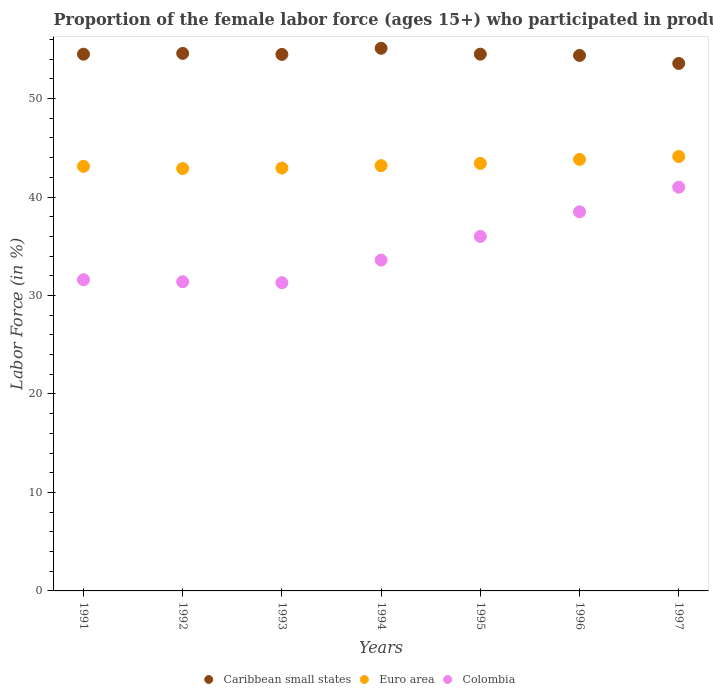How many different coloured dotlines are there?
Your response must be concise. 3. Is the number of dotlines equal to the number of legend labels?
Provide a succinct answer. Yes. What is the proportion of the female labor force who participated in production in Caribbean small states in 1995?
Your response must be concise. 54.51. Across all years, what is the maximum proportion of the female labor force who participated in production in Colombia?
Your response must be concise. 41. Across all years, what is the minimum proportion of the female labor force who participated in production in Colombia?
Keep it short and to the point. 31.3. In which year was the proportion of the female labor force who participated in production in Caribbean small states maximum?
Your response must be concise. 1994. What is the total proportion of the female labor force who participated in production in Colombia in the graph?
Ensure brevity in your answer.  243.4. What is the difference between the proportion of the female labor force who participated in production in Caribbean small states in 1993 and that in 1996?
Keep it short and to the point. 0.11. What is the difference between the proportion of the female labor force who participated in production in Caribbean small states in 1993 and the proportion of the female labor force who participated in production in Euro area in 1997?
Provide a succinct answer. 10.37. What is the average proportion of the female labor force who participated in production in Colombia per year?
Offer a terse response. 34.77. In the year 1994, what is the difference between the proportion of the female labor force who participated in production in Caribbean small states and proportion of the female labor force who participated in production in Colombia?
Your response must be concise. 21.51. In how many years, is the proportion of the female labor force who participated in production in Caribbean small states greater than 26 %?
Ensure brevity in your answer.  7. What is the ratio of the proportion of the female labor force who participated in production in Euro area in 1991 to that in 1995?
Provide a succinct answer. 0.99. Is the difference between the proportion of the female labor force who participated in production in Caribbean small states in 1993 and 1995 greater than the difference between the proportion of the female labor force who participated in production in Colombia in 1993 and 1995?
Keep it short and to the point. Yes. What is the difference between the highest and the second highest proportion of the female labor force who participated in production in Euro area?
Provide a succinct answer. 0.29. What is the difference between the highest and the lowest proportion of the female labor force who participated in production in Euro area?
Keep it short and to the point. 1.22. Is the sum of the proportion of the female labor force who participated in production in Colombia in 1994 and 1996 greater than the maximum proportion of the female labor force who participated in production in Caribbean small states across all years?
Keep it short and to the point. Yes. Is it the case that in every year, the sum of the proportion of the female labor force who participated in production in Colombia and proportion of the female labor force who participated in production in Euro area  is greater than the proportion of the female labor force who participated in production in Caribbean small states?
Make the answer very short. Yes. Does the proportion of the female labor force who participated in production in Colombia monotonically increase over the years?
Ensure brevity in your answer.  No. How many years are there in the graph?
Make the answer very short. 7. Does the graph contain grids?
Your answer should be compact. No. Where does the legend appear in the graph?
Provide a short and direct response. Bottom center. What is the title of the graph?
Your answer should be compact. Proportion of the female labor force (ages 15+) who participated in production. What is the label or title of the Y-axis?
Give a very brief answer. Labor Force (in %). What is the Labor Force (in %) of Caribbean small states in 1991?
Make the answer very short. 54.51. What is the Labor Force (in %) of Euro area in 1991?
Keep it short and to the point. 43.12. What is the Labor Force (in %) in Colombia in 1991?
Provide a succinct answer. 31.6. What is the Labor Force (in %) of Caribbean small states in 1992?
Offer a very short reply. 54.59. What is the Labor Force (in %) in Euro area in 1992?
Ensure brevity in your answer.  42.89. What is the Labor Force (in %) in Colombia in 1992?
Your answer should be compact. 31.4. What is the Labor Force (in %) in Caribbean small states in 1993?
Your response must be concise. 54.49. What is the Labor Force (in %) of Euro area in 1993?
Your answer should be compact. 42.95. What is the Labor Force (in %) of Colombia in 1993?
Ensure brevity in your answer.  31.3. What is the Labor Force (in %) in Caribbean small states in 1994?
Your answer should be very brief. 55.11. What is the Labor Force (in %) in Euro area in 1994?
Offer a terse response. 43.19. What is the Labor Force (in %) of Colombia in 1994?
Keep it short and to the point. 33.6. What is the Labor Force (in %) in Caribbean small states in 1995?
Offer a very short reply. 54.51. What is the Labor Force (in %) of Euro area in 1995?
Keep it short and to the point. 43.42. What is the Labor Force (in %) of Colombia in 1995?
Make the answer very short. 36. What is the Labor Force (in %) of Caribbean small states in 1996?
Provide a succinct answer. 54.38. What is the Labor Force (in %) in Euro area in 1996?
Make the answer very short. 43.82. What is the Labor Force (in %) of Colombia in 1996?
Give a very brief answer. 38.5. What is the Labor Force (in %) in Caribbean small states in 1997?
Provide a succinct answer. 53.57. What is the Labor Force (in %) of Euro area in 1997?
Provide a succinct answer. 44.11. What is the Labor Force (in %) in Colombia in 1997?
Keep it short and to the point. 41. Across all years, what is the maximum Labor Force (in %) of Caribbean small states?
Your response must be concise. 55.11. Across all years, what is the maximum Labor Force (in %) in Euro area?
Your answer should be very brief. 44.11. Across all years, what is the minimum Labor Force (in %) of Caribbean small states?
Make the answer very short. 53.57. Across all years, what is the minimum Labor Force (in %) in Euro area?
Your answer should be very brief. 42.89. Across all years, what is the minimum Labor Force (in %) of Colombia?
Keep it short and to the point. 31.3. What is the total Labor Force (in %) in Caribbean small states in the graph?
Keep it short and to the point. 381.14. What is the total Labor Force (in %) in Euro area in the graph?
Make the answer very short. 303.5. What is the total Labor Force (in %) in Colombia in the graph?
Your answer should be compact. 243.4. What is the difference between the Labor Force (in %) of Caribbean small states in 1991 and that in 1992?
Provide a short and direct response. -0.08. What is the difference between the Labor Force (in %) of Euro area in 1991 and that in 1992?
Make the answer very short. 0.22. What is the difference between the Labor Force (in %) of Colombia in 1991 and that in 1992?
Your answer should be very brief. 0.2. What is the difference between the Labor Force (in %) of Caribbean small states in 1991 and that in 1993?
Offer a terse response. 0.02. What is the difference between the Labor Force (in %) in Euro area in 1991 and that in 1993?
Ensure brevity in your answer.  0.17. What is the difference between the Labor Force (in %) of Caribbean small states in 1991 and that in 1994?
Offer a very short reply. -0.6. What is the difference between the Labor Force (in %) of Euro area in 1991 and that in 1994?
Keep it short and to the point. -0.07. What is the difference between the Labor Force (in %) in Colombia in 1991 and that in 1994?
Your answer should be very brief. -2. What is the difference between the Labor Force (in %) in Caribbean small states in 1991 and that in 1995?
Offer a terse response. -0. What is the difference between the Labor Force (in %) of Euro area in 1991 and that in 1995?
Your response must be concise. -0.3. What is the difference between the Labor Force (in %) in Colombia in 1991 and that in 1995?
Give a very brief answer. -4.4. What is the difference between the Labor Force (in %) of Caribbean small states in 1991 and that in 1996?
Make the answer very short. 0.13. What is the difference between the Labor Force (in %) of Euro area in 1991 and that in 1996?
Make the answer very short. -0.7. What is the difference between the Labor Force (in %) in Colombia in 1991 and that in 1996?
Keep it short and to the point. -6.9. What is the difference between the Labor Force (in %) in Caribbean small states in 1991 and that in 1997?
Offer a terse response. 0.94. What is the difference between the Labor Force (in %) of Euro area in 1991 and that in 1997?
Offer a very short reply. -0.99. What is the difference between the Labor Force (in %) in Caribbean small states in 1992 and that in 1993?
Provide a succinct answer. 0.1. What is the difference between the Labor Force (in %) in Euro area in 1992 and that in 1993?
Keep it short and to the point. -0.05. What is the difference between the Labor Force (in %) of Colombia in 1992 and that in 1993?
Your answer should be compact. 0.1. What is the difference between the Labor Force (in %) in Caribbean small states in 1992 and that in 1994?
Offer a terse response. -0.52. What is the difference between the Labor Force (in %) of Euro area in 1992 and that in 1994?
Ensure brevity in your answer.  -0.29. What is the difference between the Labor Force (in %) of Caribbean small states in 1992 and that in 1995?
Provide a short and direct response. 0.08. What is the difference between the Labor Force (in %) of Euro area in 1992 and that in 1995?
Provide a succinct answer. -0.52. What is the difference between the Labor Force (in %) of Colombia in 1992 and that in 1995?
Keep it short and to the point. -4.6. What is the difference between the Labor Force (in %) of Caribbean small states in 1992 and that in 1996?
Your answer should be compact. 0.21. What is the difference between the Labor Force (in %) of Euro area in 1992 and that in 1996?
Give a very brief answer. -0.93. What is the difference between the Labor Force (in %) of Caribbean small states in 1992 and that in 1997?
Your response must be concise. 1.02. What is the difference between the Labor Force (in %) of Euro area in 1992 and that in 1997?
Keep it short and to the point. -1.22. What is the difference between the Labor Force (in %) in Caribbean small states in 1993 and that in 1994?
Provide a succinct answer. -0.62. What is the difference between the Labor Force (in %) in Euro area in 1993 and that in 1994?
Offer a terse response. -0.24. What is the difference between the Labor Force (in %) in Colombia in 1993 and that in 1994?
Your answer should be compact. -2.3. What is the difference between the Labor Force (in %) of Caribbean small states in 1993 and that in 1995?
Ensure brevity in your answer.  -0.02. What is the difference between the Labor Force (in %) of Euro area in 1993 and that in 1995?
Offer a very short reply. -0.47. What is the difference between the Labor Force (in %) of Caribbean small states in 1993 and that in 1996?
Your answer should be compact. 0.11. What is the difference between the Labor Force (in %) of Euro area in 1993 and that in 1996?
Keep it short and to the point. -0.87. What is the difference between the Labor Force (in %) of Caribbean small states in 1993 and that in 1997?
Your answer should be compact. 0.92. What is the difference between the Labor Force (in %) of Euro area in 1993 and that in 1997?
Your response must be concise. -1.17. What is the difference between the Labor Force (in %) of Caribbean small states in 1994 and that in 1995?
Ensure brevity in your answer.  0.6. What is the difference between the Labor Force (in %) in Euro area in 1994 and that in 1995?
Give a very brief answer. -0.23. What is the difference between the Labor Force (in %) in Colombia in 1994 and that in 1995?
Your answer should be very brief. -2.4. What is the difference between the Labor Force (in %) in Caribbean small states in 1994 and that in 1996?
Offer a terse response. 0.73. What is the difference between the Labor Force (in %) in Euro area in 1994 and that in 1996?
Your answer should be compact. -0.63. What is the difference between the Labor Force (in %) in Colombia in 1994 and that in 1996?
Provide a succinct answer. -4.9. What is the difference between the Labor Force (in %) in Caribbean small states in 1994 and that in 1997?
Your response must be concise. 1.54. What is the difference between the Labor Force (in %) of Euro area in 1994 and that in 1997?
Give a very brief answer. -0.92. What is the difference between the Labor Force (in %) of Colombia in 1994 and that in 1997?
Offer a terse response. -7.4. What is the difference between the Labor Force (in %) of Caribbean small states in 1995 and that in 1996?
Ensure brevity in your answer.  0.13. What is the difference between the Labor Force (in %) in Euro area in 1995 and that in 1996?
Keep it short and to the point. -0.4. What is the difference between the Labor Force (in %) in Colombia in 1995 and that in 1996?
Offer a terse response. -2.5. What is the difference between the Labor Force (in %) in Caribbean small states in 1995 and that in 1997?
Provide a short and direct response. 0.94. What is the difference between the Labor Force (in %) in Euro area in 1995 and that in 1997?
Your answer should be very brief. -0.69. What is the difference between the Labor Force (in %) in Colombia in 1995 and that in 1997?
Your answer should be very brief. -5. What is the difference between the Labor Force (in %) in Caribbean small states in 1996 and that in 1997?
Your response must be concise. 0.81. What is the difference between the Labor Force (in %) of Euro area in 1996 and that in 1997?
Provide a succinct answer. -0.29. What is the difference between the Labor Force (in %) in Colombia in 1996 and that in 1997?
Offer a terse response. -2.5. What is the difference between the Labor Force (in %) of Caribbean small states in 1991 and the Labor Force (in %) of Euro area in 1992?
Your response must be concise. 11.61. What is the difference between the Labor Force (in %) in Caribbean small states in 1991 and the Labor Force (in %) in Colombia in 1992?
Make the answer very short. 23.11. What is the difference between the Labor Force (in %) in Euro area in 1991 and the Labor Force (in %) in Colombia in 1992?
Ensure brevity in your answer.  11.72. What is the difference between the Labor Force (in %) of Caribbean small states in 1991 and the Labor Force (in %) of Euro area in 1993?
Provide a succinct answer. 11.56. What is the difference between the Labor Force (in %) in Caribbean small states in 1991 and the Labor Force (in %) in Colombia in 1993?
Keep it short and to the point. 23.21. What is the difference between the Labor Force (in %) in Euro area in 1991 and the Labor Force (in %) in Colombia in 1993?
Provide a succinct answer. 11.82. What is the difference between the Labor Force (in %) in Caribbean small states in 1991 and the Labor Force (in %) in Euro area in 1994?
Give a very brief answer. 11.32. What is the difference between the Labor Force (in %) of Caribbean small states in 1991 and the Labor Force (in %) of Colombia in 1994?
Your answer should be very brief. 20.91. What is the difference between the Labor Force (in %) in Euro area in 1991 and the Labor Force (in %) in Colombia in 1994?
Offer a terse response. 9.52. What is the difference between the Labor Force (in %) of Caribbean small states in 1991 and the Labor Force (in %) of Euro area in 1995?
Provide a succinct answer. 11.09. What is the difference between the Labor Force (in %) in Caribbean small states in 1991 and the Labor Force (in %) in Colombia in 1995?
Keep it short and to the point. 18.51. What is the difference between the Labor Force (in %) in Euro area in 1991 and the Labor Force (in %) in Colombia in 1995?
Make the answer very short. 7.12. What is the difference between the Labor Force (in %) of Caribbean small states in 1991 and the Labor Force (in %) of Euro area in 1996?
Give a very brief answer. 10.69. What is the difference between the Labor Force (in %) in Caribbean small states in 1991 and the Labor Force (in %) in Colombia in 1996?
Offer a terse response. 16.01. What is the difference between the Labor Force (in %) in Euro area in 1991 and the Labor Force (in %) in Colombia in 1996?
Your answer should be compact. 4.62. What is the difference between the Labor Force (in %) in Caribbean small states in 1991 and the Labor Force (in %) in Euro area in 1997?
Make the answer very short. 10.39. What is the difference between the Labor Force (in %) in Caribbean small states in 1991 and the Labor Force (in %) in Colombia in 1997?
Keep it short and to the point. 13.51. What is the difference between the Labor Force (in %) of Euro area in 1991 and the Labor Force (in %) of Colombia in 1997?
Your answer should be very brief. 2.12. What is the difference between the Labor Force (in %) of Caribbean small states in 1992 and the Labor Force (in %) of Euro area in 1993?
Keep it short and to the point. 11.64. What is the difference between the Labor Force (in %) in Caribbean small states in 1992 and the Labor Force (in %) in Colombia in 1993?
Provide a short and direct response. 23.29. What is the difference between the Labor Force (in %) in Euro area in 1992 and the Labor Force (in %) in Colombia in 1993?
Your answer should be compact. 11.59. What is the difference between the Labor Force (in %) of Caribbean small states in 1992 and the Labor Force (in %) of Euro area in 1994?
Your response must be concise. 11.4. What is the difference between the Labor Force (in %) of Caribbean small states in 1992 and the Labor Force (in %) of Colombia in 1994?
Your answer should be very brief. 20.99. What is the difference between the Labor Force (in %) of Euro area in 1992 and the Labor Force (in %) of Colombia in 1994?
Provide a short and direct response. 9.29. What is the difference between the Labor Force (in %) in Caribbean small states in 1992 and the Labor Force (in %) in Euro area in 1995?
Offer a very short reply. 11.17. What is the difference between the Labor Force (in %) of Caribbean small states in 1992 and the Labor Force (in %) of Colombia in 1995?
Ensure brevity in your answer.  18.59. What is the difference between the Labor Force (in %) of Euro area in 1992 and the Labor Force (in %) of Colombia in 1995?
Offer a very short reply. 6.89. What is the difference between the Labor Force (in %) of Caribbean small states in 1992 and the Labor Force (in %) of Euro area in 1996?
Your answer should be very brief. 10.77. What is the difference between the Labor Force (in %) in Caribbean small states in 1992 and the Labor Force (in %) in Colombia in 1996?
Give a very brief answer. 16.09. What is the difference between the Labor Force (in %) of Euro area in 1992 and the Labor Force (in %) of Colombia in 1996?
Ensure brevity in your answer.  4.39. What is the difference between the Labor Force (in %) of Caribbean small states in 1992 and the Labor Force (in %) of Euro area in 1997?
Provide a short and direct response. 10.47. What is the difference between the Labor Force (in %) in Caribbean small states in 1992 and the Labor Force (in %) in Colombia in 1997?
Provide a short and direct response. 13.59. What is the difference between the Labor Force (in %) of Euro area in 1992 and the Labor Force (in %) of Colombia in 1997?
Give a very brief answer. 1.89. What is the difference between the Labor Force (in %) in Caribbean small states in 1993 and the Labor Force (in %) in Euro area in 1994?
Offer a very short reply. 11.3. What is the difference between the Labor Force (in %) in Caribbean small states in 1993 and the Labor Force (in %) in Colombia in 1994?
Your response must be concise. 20.89. What is the difference between the Labor Force (in %) of Euro area in 1993 and the Labor Force (in %) of Colombia in 1994?
Provide a succinct answer. 9.35. What is the difference between the Labor Force (in %) of Caribbean small states in 1993 and the Labor Force (in %) of Euro area in 1995?
Keep it short and to the point. 11.07. What is the difference between the Labor Force (in %) of Caribbean small states in 1993 and the Labor Force (in %) of Colombia in 1995?
Your answer should be very brief. 18.49. What is the difference between the Labor Force (in %) in Euro area in 1993 and the Labor Force (in %) in Colombia in 1995?
Your response must be concise. 6.95. What is the difference between the Labor Force (in %) in Caribbean small states in 1993 and the Labor Force (in %) in Euro area in 1996?
Provide a succinct answer. 10.66. What is the difference between the Labor Force (in %) in Caribbean small states in 1993 and the Labor Force (in %) in Colombia in 1996?
Your response must be concise. 15.99. What is the difference between the Labor Force (in %) of Euro area in 1993 and the Labor Force (in %) of Colombia in 1996?
Your answer should be very brief. 4.45. What is the difference between the Labor Force (in %) of Caribbean small states in 1993 and the Labor Force (in %) of Euro area in 1997?
Offer a very short reply. 10.37. What is the difference between the Labor Force (in %) of Caribbean small states in 1993 and the Labor Force (in %) of Colombia in 1997?
Provide a succinct answer. 13.49. What is the difference between the Labor Force (in %) of Euro area in 1993 and the Labor Force (in %) of Colombia in 1997?
Your response must be concise. 1.95. What is the difference between the Labor Force (in %) in Caribbean small states in 1994 and the Labor Force (in %) in Euro area in 1995?
Offer a terse response. 11.69. What is the difference between the Labor Force (in %) of Caribbean small states in 1994 and the Labor Force (in %) of Colombia in 1995?
Provide a succinct answer. 19.11. What is the difference between the Labor Force (in %) of Euro area in 1994 and the Labor Force (in %) of Colombia in 1995?
Your answer should be compact. 7.19. What is the difference between the Labor Force (in %) of Caribbean small states in 1994 and the Labor Force (in %) of Euro area in 1996?
Provide a short and direct response. 11.28. What is the difference between the Labor Force (in %) in Caribbean small states in 1994 and the Labor Force (in %) in Colombia in 1996?
Offer a terse response. 16.61. What is the difference between the Labor Force (in %) in Euro area in 1994 and the Labor Force (in %) in Colombia in 1996?
Make the answer very short. 4.69. What is the difference between the Labor Force (in %) of Caribbean small states in 1994 and the Labor Force (in %) of Euro area in 1997?
Offer a terse response. 10.99. What is the difference between the Labor Force (in %) in Caribbean small states in 1994 and the Labor Force (in %) in Colombia in 1997?
Offer a terse response. 14.11. What is the difference between the Labor Force (in %) in Euro area in 1994 and the Labor Force (in %) in Colombia in 1997?
Your answer should be very brief. 2.19. What is the difference between the Labor Force (in %) of Caribbean small states in 1995 and the Labor Force (in %) of Euro area in 1996?
Your response must be concise. 10.69. What is the difference between the Labor Force (in %) of Caribbean small states in 1995 and the Labor Force (in %) of Colombia in 1996?
Keep it short and to the point. 16.01. What is the difference between the Labor Force (in %) of Euro area in 1995 and the Labor Force (in %) of Colombia in 1996?
Offer a very short reply. 4.92. What is the difference between the Labor Force (in %) of Caribbean small states in 1995 and the Labor Force (in %) of Euro area in 1997?
Offer a terse response. 10.4. What is the difference between the Labor Force (in %) of Caribbean small states in 1995 and the Labor Force (in %) of Colombia in 1997?
Your answer should be compact. 13.51. What is the difference between the Labor Force (in %) of Euro area in 1995 and the Labor Force (in %) of Colombia in 1997?
Ensure brevity in your answer.  2.42. What is the difference between the Labor Force (in %) in Caribbean small states in 1996 and the Labor Force (in %) in Euro area in 1997?
Your answer should be very brief. 10.27. What is the difference between the Labor Force (in %) of Caribbean small states in 1996 and the Labor Force (in %) of Colombia in 1997?
Ensure brevity in your answer.  13.38. What is the difference between the Labor Force (in %) of Euro area in 1996 and the Labor Force (in %) of Colombia in 1997?
Provide a succinct answer. 2.82. What is the average Labor Force (in %) of Caribbean small states per year?
Make the answer very short. 54.45. What is the average Labor Force (in %) in Euro area per year?
Give a very brief answer. 43.36. What is the average Labor Force (in %) in Colombia per year?
Provide a short and direct response. 34.77. In the year 1991, what is the difference between the Labor Force (in %) in Caribbean small states and Labor Force (in %) in Euro area?
Provide a short and direct response. 11.39. In the year 1991, what is the difference between the Labor Force (in %) in Caribbean small states and Labor Force (in %) in Colombia?
Give a very brief answer. 22.91. In the year 1991, what is the difference between the Labor Force (in %) of Euro area and Labor Force (in %) of Colombia?
Offer a terse response. 11.52. In the year 1992, what is the difference between the Labor Force (in %) in Caribbean small states and Labor Force (in %) in Euro area?
Offer a very short reply. 11.69. In the year 1992, what is the difference between the Labor Force (in %) in Caribbean small states and Labor Force (in %) in Colombia?
Give a very brief answer. 23.19. In the year 1992, what is the difference between the Labor Force (in %) in Euro area and Labor Force (in %) in Colombia?
Your answer should be very brief. 11.49. In the year 1993, what is the difference between the Labor Force (in %) of Caribbean small states and Labor Force (in %) of Euro area?
Give a very brief answer. 11.54. In the year 1993, what is the difference between the Labor Force (in %) in Caribbean small states and Labor Force (in %) in Colombia?
Your response must be concise. 23.19. In the year 1993, what is the difference between the Labor Force (in %) in Euro area and Labor Force (in %) in Colombia?
Give a very brief answer. 11.65. In the year 1994, what is the difference between the Labor Force (in %) of Caribbean small states and Labor Force (in %) of Euro area?
Your response must be concise. 11.92. In the year 1994, what is the difference between the Labor Force (in %) in Caribbean small states and Labor Force (in %) in Colombia?
Your answer should be very brief. 21.51. In the year 1994, what is the difference between the Labor Force (in %) in Euro area and Labor Force (in %) in Colombia?
Your response must be concise. 9.59. In the year 1995, what is the difference between the Labor Force (in %) in Caribbean small states and Labor Force (in %) in Euro area?
Offer a terse response. 11.09. In the year 1995, what is the difference between the Labor Force (in %) in Caribbean small states and Labor Force (in %) in Colombia?
Give a very brief answer. 18.51. In the year 1995, what is the difference between the Labor Force (in %) of Euro area and Labor Force (in %) of Colombia?
Provide a short and direct response. 7.42. In the year 1996, what is the difference between the Labor Force (in %) in Caribbean small states and Labor Force (in %) in Euro area?
Make the answer very short. 10.56. In the year 1996, what is the difference between the Labor Force (in %) of Caribbean small states and Labor Force (in %) of Colombia?
Keep it short and to the point. 15.88. In the year 1996, what is the difference between the Labor Force (in %) in Euro area and Labor Force (in %) in Colombia?
Offer a terse response. 5.32. In the year 1997, what is the difference between the Labor Force (in %) in Caribbean small states and Labor Force (in %) in Euro area?
Offer a terse response. 9.45. In the year 1997, what is the difference between the Labor Force (in %) in Caribbean small states and Labor Force (in %) in Colombia?
Ensure brevity in your answer.  12.57. In the year 1997, what is the difference between the Labor Force (in %) of Euro area and Labor Force (in %) of Colombia?
Ensure brevity in your answer.  3.11. What is the ratio of the Labor Force (in %) of Euro area in 1991 to that in 1992?
Provide a short and direct response. 1.01. What is the ratio of the Labor Force (in %) in Colombia in 1991 to that in 1992?
Keep it short and to the point. 1.01. What is the ratio of the Labor Force (in %) of Colombia in 1991 to that in 1993?
Give a very brief answer. 1.01. What is the ratio of the Labor Force (in %) in Euro area in 1991 to that in 1994?
Offer a terse response. 1. What is the ratio of the Labor Force (in %) of Colombia in 1991 to that in 1994?
Provide a short and direct response. 0.94. What is the ratio of the Labor Force (in %) of Euro area in 1991 to that in 1995?
Offer a terse response. 0.99. What is the ratio of the Labor Force (in %) of Colombia in 1991 to that in 1995?
Ensure brevity in your answer.  0.88. What is the ratio of the Labor Force (in %) of Caribbean small states in 1991 to that in 1996?
Your answer should be compact. 1. What is the ratio of the Labor Force (in %) in Euro area in 1991 to that in 1996?
Your answer should be very brief. 0.98. What is the ratio of the Labor Force (in %) of Colombia in 1991 to that in 1996?
Offer a terse response. 0.82. What is the ratio of the Labor Force (in %) in Caribbean small states in 1991 to that in 1997?
Your answer should be compact. 1.02. What is the ratio of the Labor Force (in %) of Euro area in 1991 to that in 1997?
Your response must be concise. 0.98. What is the ratio of the Labor Force (in %) of Colombia in 1991 to that in 1997?
Keep it short and to the point. 0.77. What is the ratio of the Labor Force (in %) in Colombia in 1992 to that in 1993?
Your answer should be very brief. 1. What is the ratio of the Labor Force (in %) in Caribbean small states in 1992 to that in 1994?
Offer a very short reply. 0.99. What is the ratio of the Labor Force (in %) of Euro area in 1992 to that in 1994?
Offer a very short reply. 0.99. What is the ratio of the Labor Force (in %) of Colombia in 1992 to that in 1994?
Give a very brief answer. 0.93. What is the ratio of the Labor Force (in %) of Euro area in 1992 to that in 1995?
Ensure brevity in your answer.  0.99. What is the ratio of the Labor Force (in %) of Colombia in 1992 to that in 1995?
Your answer should be compact. 0.87. What is the ratio of the Labor Force (in %) of Caribbean small states in 1992 to that in 1996?
Keep it short and to the point. 1. What is the ratio of the Labor Force (in %) in Euro area in 1992 to that in 1996?
Give a very brief answer. 0.98. What is the ratio of the Labor Force (in %) in Colombia in 1992 to that in 1996?
Provide a succinct answer. 0.82. What is the ratio of the Labor Force (in %) in Caribbean small states in 1992 to that in 1997?
Give a very brief answer. 1.02. What is the ratio of the Labor Force (in %) of Euro area in 1992 to that in 1997?
Give a very brief answer. 0.97. What is the ratio of the Labor Force (in %) of Colombia in 1992 to that in 1997?
Give a very brief answer. 0.77. What is the ratio of the Labor Force (in %) in Caribbean small states in 1993 to that in 1994?
Give a very brief answer. 0.99. What is the ratio of the Labor Force (in %) of Colombia in 1993 to that in 1994?
Keep it short and to the point. 0.93. What is the ratio of the Labor Force (in %) of Caribbean small states in 1993 to that in 1995?
Provide a short and direct response. 1. What is the ratio of the Labor Force (in %) of Euro area in 1993 to that in 1995?
Offer a terse response. 0.99. What is the ratio of the Labor Force (in %) in Colombia in 1993 to that in 1995?
Give a very brief answer. 0.87. What is the ratio of the Labor Force (in %) in Caribbean small states in 1993 to that in 1996?
Offer a terse response. 1. What is the ratio of the Labor Force (in %) of Euro area in 1993 to that in 1996?
Give a very brief answer. 0.98. What is the ratio of the Labor Force (in %) of Colombia in 1993 to that in 1996?
Provide a short and direct response. 0.81. What is the ratio of the Labor Force (in %) of Caribbean small states in 1993 to that in 1997?
Provide a succinct answer. 1.02. What is the ratio of the Labor Force (in %) in Euro area in 1993 to that in 1997?
Provide a short and direct response. 0.97. What is the ratio of the Labor Force (in %) in Colombia in 1993 to that in 1997?
Provide a succinct answer. 0.76. What is the ratio of the Labor Force (in %) of Caribbean small states in 1994 to that in 1995?
Your answer should be very brief. 1.01. What is the ratio of the Labor Force (in %) of Caribbean small states in 1994 to that in 1996?
Give a very brief answer. 1.01. What is the ratio of the Labor Force (in %) in Euro area in 1994 to that in 1996?
Offer a very short reply. 0.99. What is the ratio of the Labor Force (in %) of Colombia in 1994 to that in 1996?
Provide a succinct answer. 0.87. What is the ratio of the Labor Force (in %) of Caribbean small states in 1994 to that in 1997?
Offer a terse response. 1.03. What is the ratio of the Labor Force (in %) in Colombia in 1994 to that in 1997?
Offer a very short reply. 0.82. What is the ratio of the Labor Force (in %) in Caribbean small states in 1995 to that in 1996?
Keep it short and to the point. 1. What is the ratio of the Labor Force (in %) in Colombia in 1995 to that in 1996?
Provide a succinct answer. 0.94. What is the ratio of the Labor Force (in %) of Caribbean small states in 1995 to that in 1997?
Provide a succinct answer. 1.02. What is the ratio of the Labor Force (in %) in Euro area in 1995 to that in 1997?
Offer a terse response. 0.98. What is the ratio of the Labor Force (in %) of Colombia in 1995 to that in 1997?
Provide a short and direct response. 0.88. What is the ratio of the Labor Force (in %) of Caribbean small states in 1996 to that in 1997?
Give a very brief answer. 1.02. What is the ratio of the Labor Force (in %) of Colombia in 1996 to that in 1997?
Provide a succinct answer. 0.94. What is the difference between the highest and the second highest Labor Force (in %) of Caribbean small states?
Ensure brevity in your answer.  0.52. What is the difference between the highest and the second highest Labor Force (in %) in Euro area?
Ensure brevity in your answer.  0.29. What is the difference between the highest and the second highest Labor Force (in %) in Colombia?
Offer a terse response. 2.5. What is the difference between the highest and the lowest Labor Force (in %) of Caribbean small states?
Provide a succinct answer. 1.54. What is the difference between the highest and the lowest Labor Force (in %) of Euro area?
Make the answer very short. 1.22. What is the difference between the highest and the lowest Labor Force (in %) of Colombia?
Offer a very short reply. 9.7. 